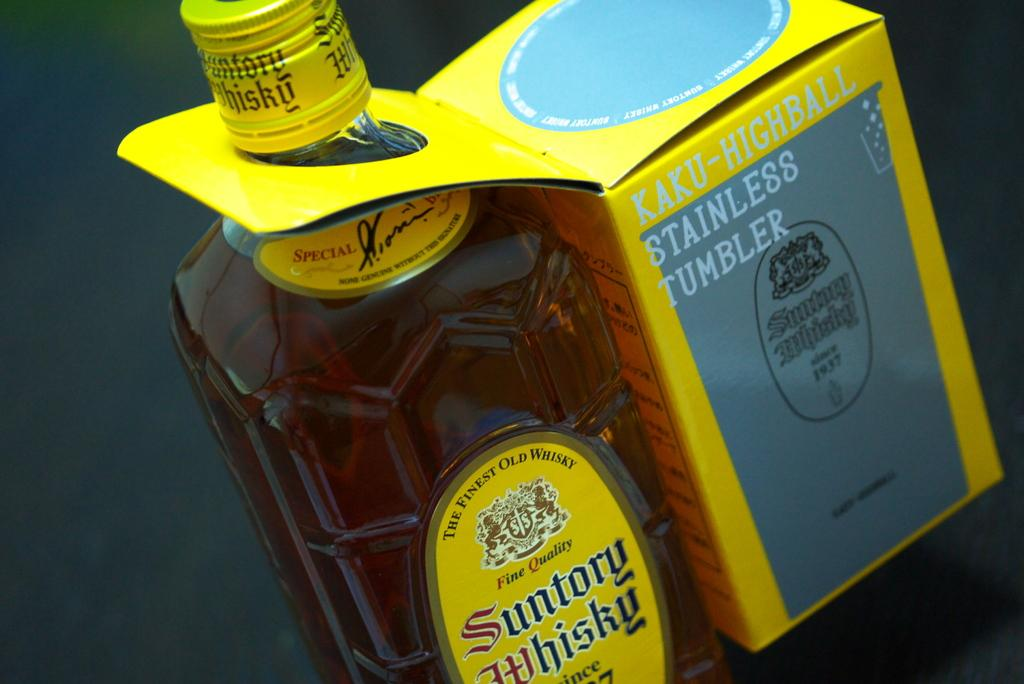<image>
Give a short and clear explanation of the subsequent image. A bottle of Suntory Whisky comes with a stainless highball tumbler attached. 